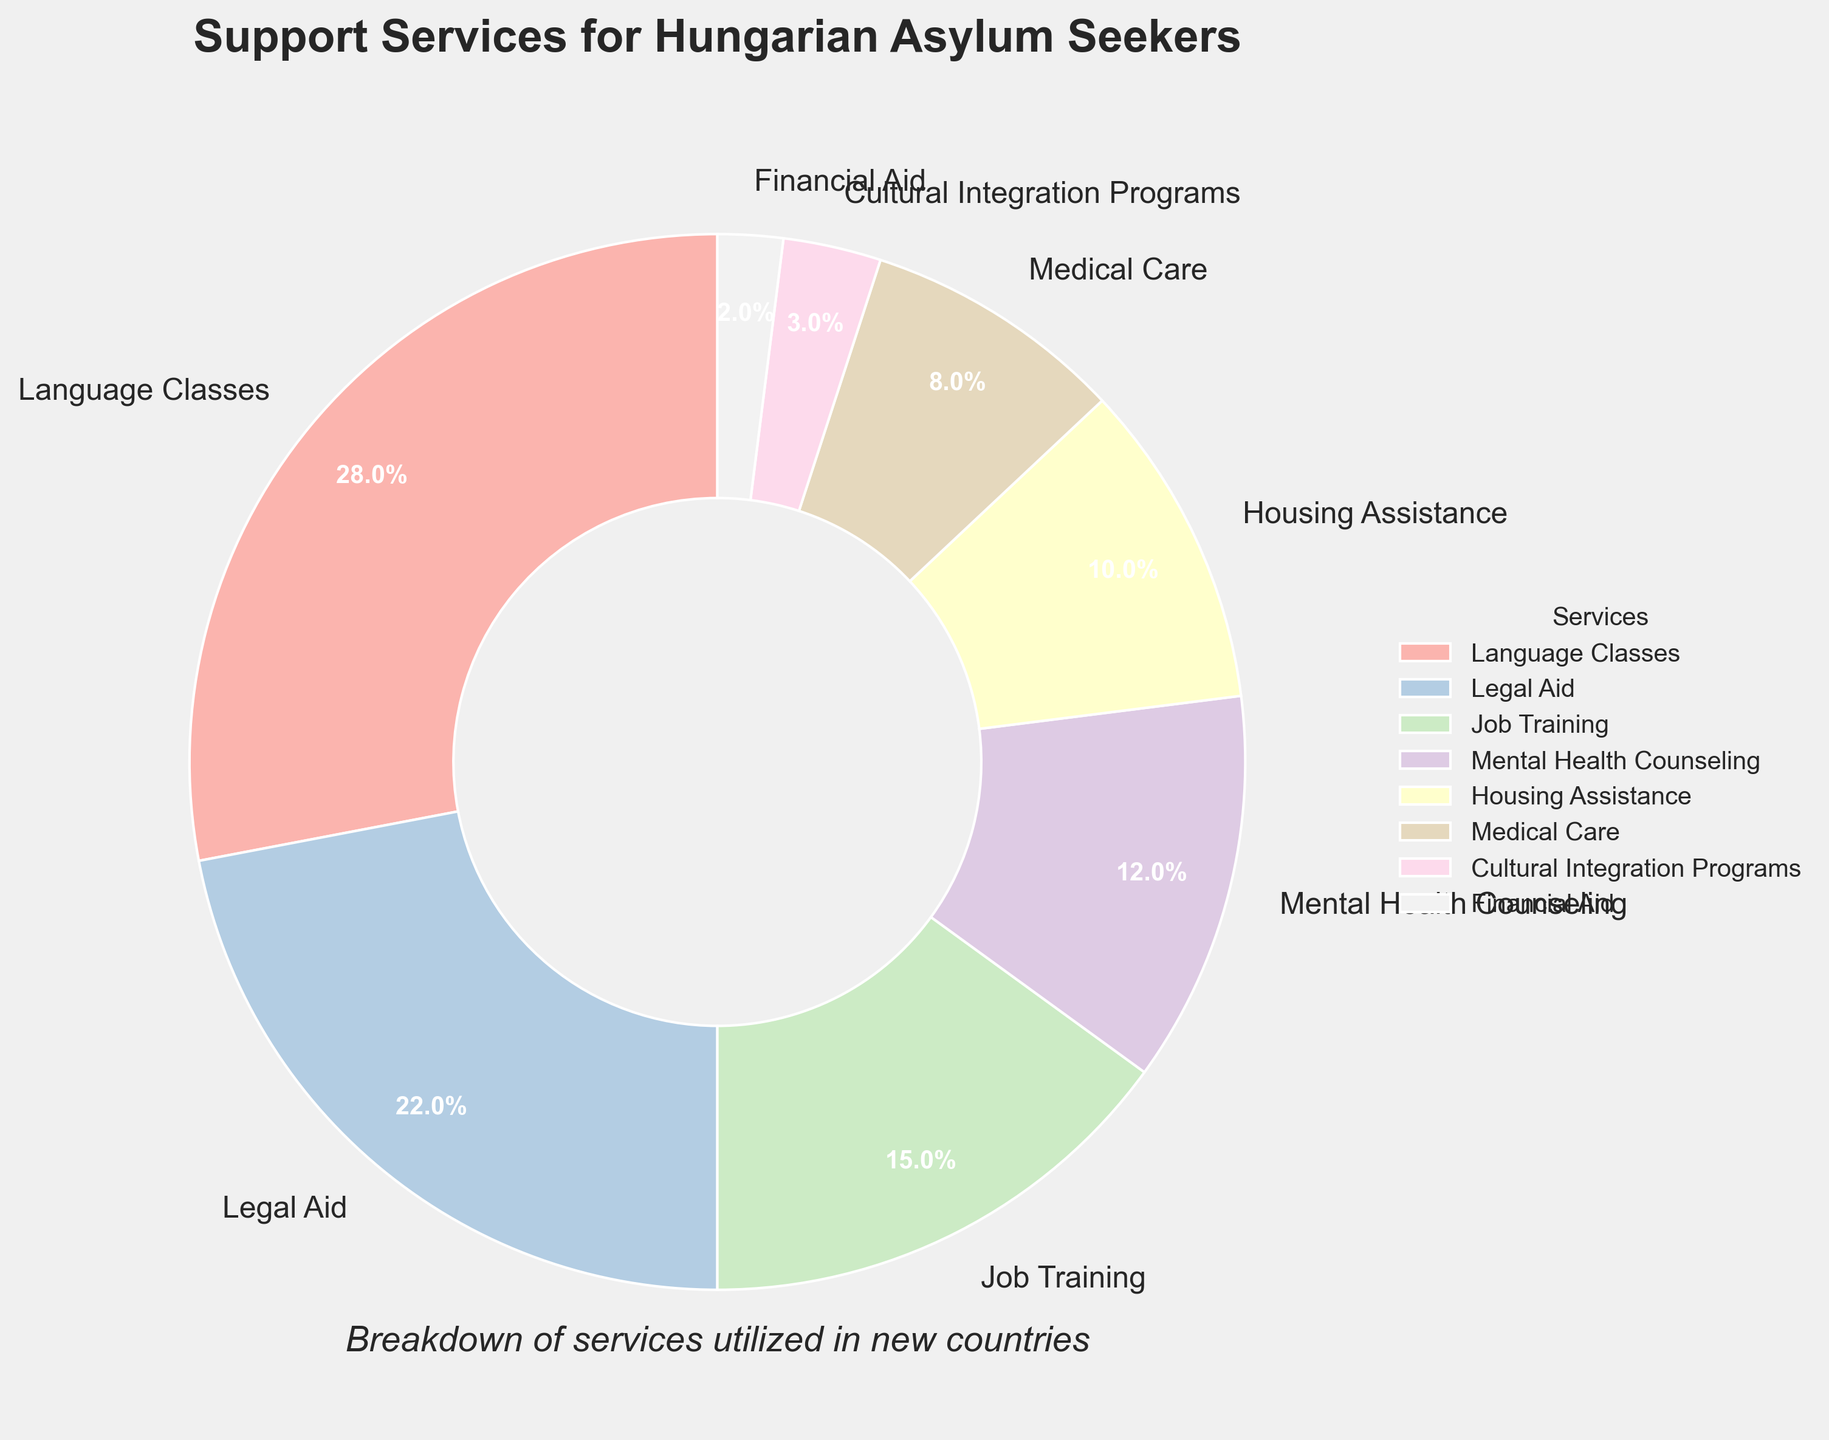What percentage of asylum seekers utilized Mental Health Counseling? Look for the slice labeled "Mental Health Counseling" in the pie chart and read its percentage value.
Answer: 12% Which service is utilized more: Language Classes or Job Training? Identify the percentage values for both Language Classes (28%) and Job Training (15%) and compare them. Language Classes has a higher percentage.
Answer: Language Classes What is the difference in percentage between Medical Care and Financial Aid? Find the percentage values for Medical Care (8%) and Financial Aid (2%), then subtract the smaller percentage from the larger one (8% - 2%).
Answer: 6% What is the total percentage of services utilized that are above 20%? Identify the services with percentages above 20% (Language Classes at 28%, Legal Aid at 22%), and sum them (28% + 22%).
Answer: 50% Which service is represented by the smallest slice in the pie chart? Look for the smallest slice in the pie chart and read its label.
Answer: Financial Aid Is Housing Assistance utilized more than Medical Care? Compare the percentage values for Housing Assistance (10%) and Medical Care (8%). Housing Assistance has a higher percentage.
Answer: Yes What is the combined percentage of services related to employment (Job Training) and accommodations (Housing Assistance)? Identify the percentage values for Job Training (15%) and Housing Assistance (10%) and add them together (15% + 10%).
Answer: 25% What visual feature helps you quickly identify the largest service utilized by asylum seekers? The largest slice in the pie chart is the visual feature that indicates the service with the highest percentage.
Answer: The largest slice How many services have a utilization percentage of less than 10%? Identify slices with percentages less than 10% (Medical Care at 8%, Cultural Integration Programs at 3%, Financial Aid at 2%) and count them.
Answer: 3 What is the sum of the percentages for Cultural Integration Programs and Financial Aid? Find the percentage values for Cultural Integration Programs (3%) and Financial Aid (2%), then add them together (3% + 2%).
Answer: 5% 